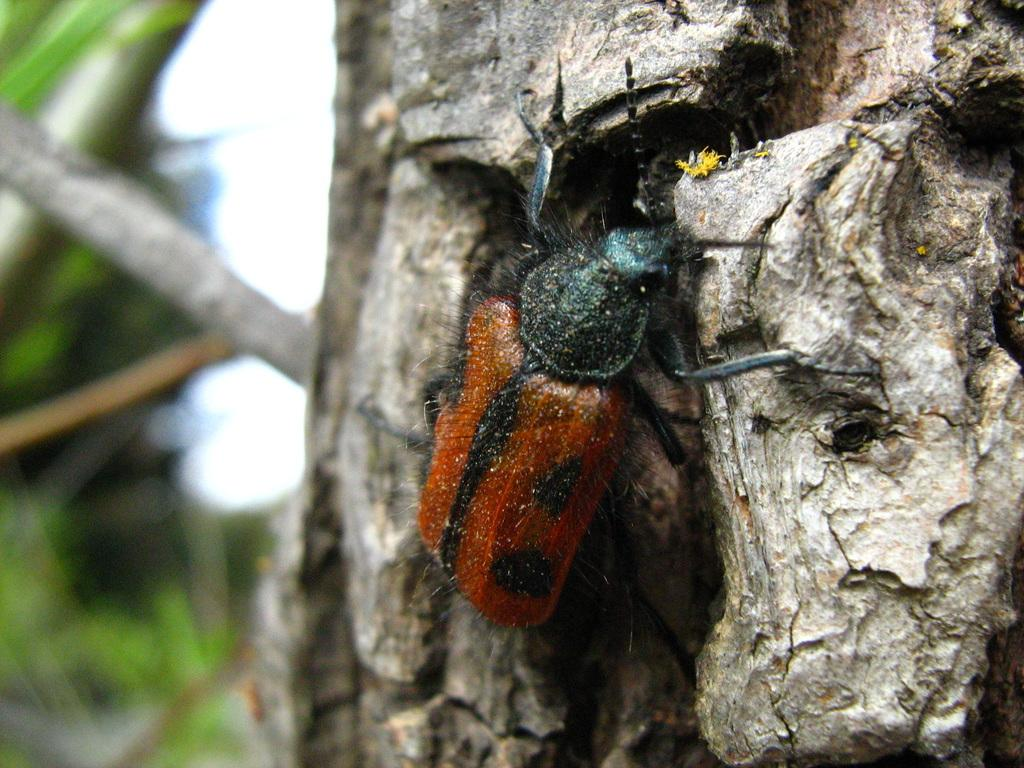What is the main subject of the image? The main subject of the image is an insect on a wooden trunk. Where is the insect located in the image? The insect is in the middle of the image. What color can be seen on the left side of the image? There is green color on the left side of the image. What type of comfort does the insect provide in the image? The image does not depict the insect providing any comfort. What other thing can be seen in the image besides the insect and the wooden trunk? The provided facts do not mention any other objects or subjects in the image besides the insect and the wooden trunk. 